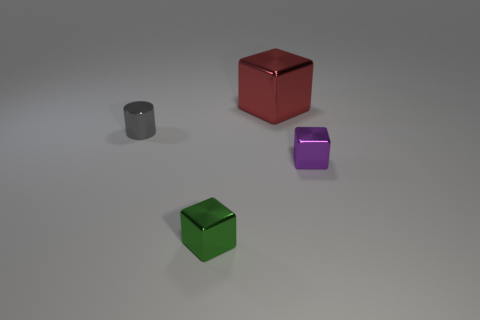How many other things are there of the same material as the red cube?
Keep it short and to the point. 3. How many other things have the same size as the green thing?
Ensure brevity in your answer.  2. There is a tiny object that is behind the metal cube that is to the right of the big red cube; how many tiny green blocks are behind it?
Offer a terse response. 0. Is the number of tiny gray metallic cylinders in front of the small green block the same as the number of red metallic blocks that are behind the big metal thing?
Ensure brevity in your answer.  Yes. How many big gray metal things have the same shape as the purple thing?
Provide a short and direct response. 0. Are there any big cubes made of the same material as the red object?
Your response must be concise. No. How many small blocks are there?
Offer a very short reply. 2. How many balls are cyan rubber objects or green objects?
Offer a very short reply. 0. There is another block that is the same size as the green block; what color is it?
Provide a succinct answer. Purple. How many things are left of the purple metal cube and in front of the small cylinder?
Your answer should be very brief. 1. 